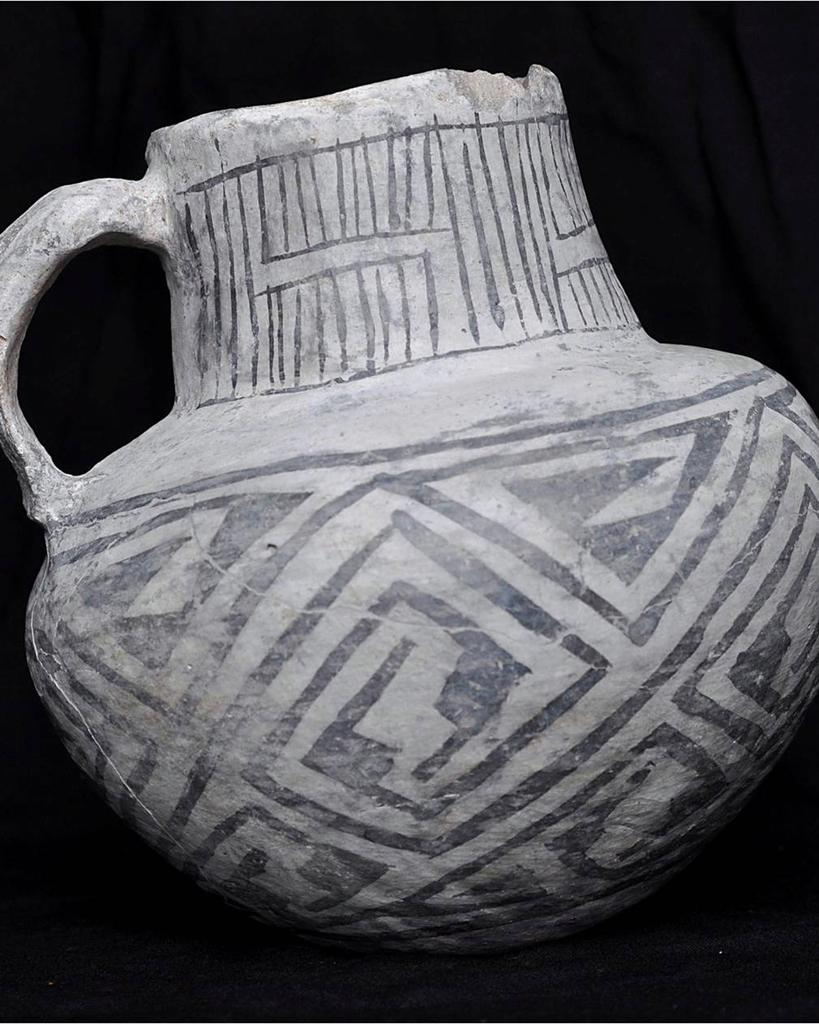What type of material is featured in the image? There is stoneware in the image. Can you describe the background of the image? The background of the image is dark. What type of soda is being served in the stoneware in the image? There is no soda present in the image; it only features stoneware. Can you tell me the name of the minister who is blessing the stoneware in the image? There is no minister or any religious ceremony depicted in the image; it only features stoneware and a dark background. 